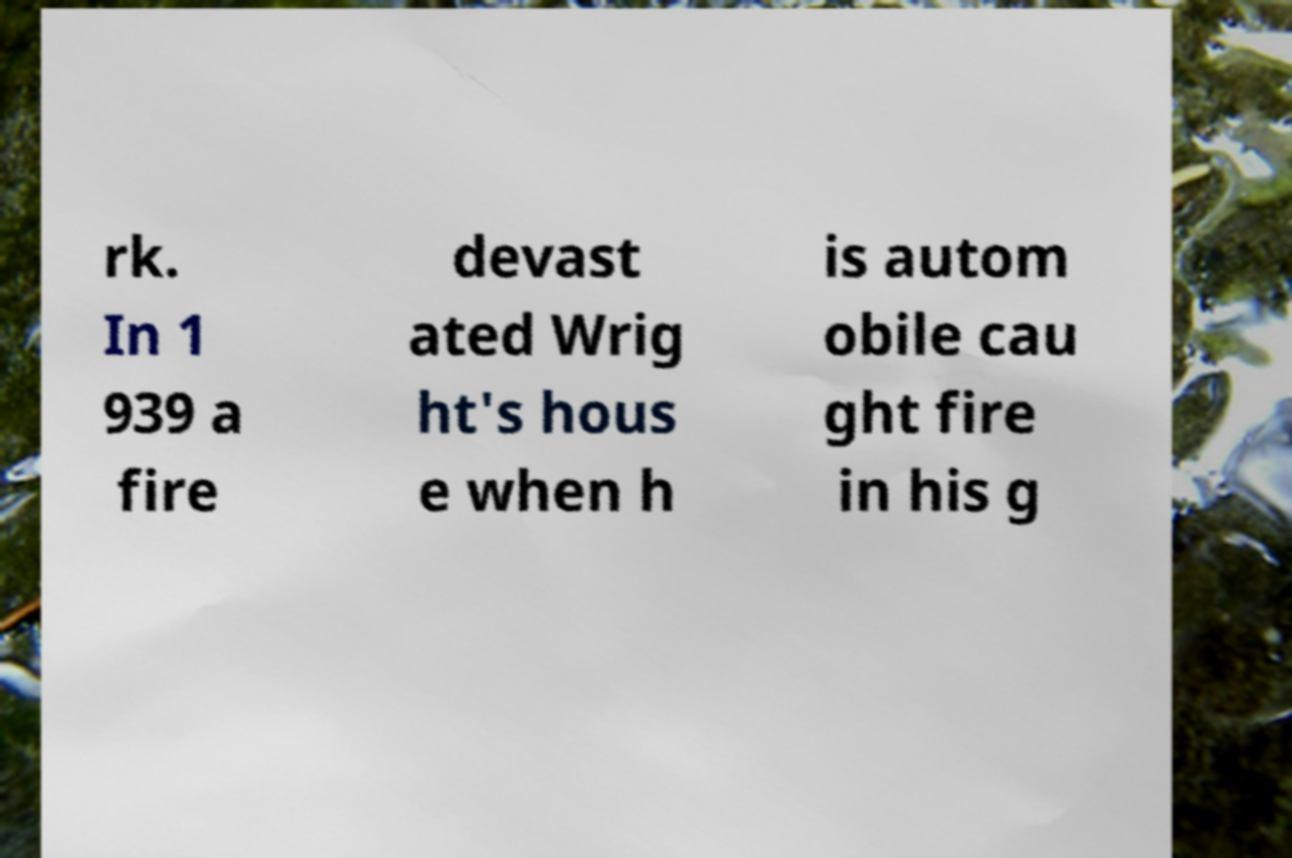Can you accurately transcribe the text from the provided image for me? rk. In 1 939 a fire devast ated Wrig ht's hous e when h is autom obile cau ght fire in his g 